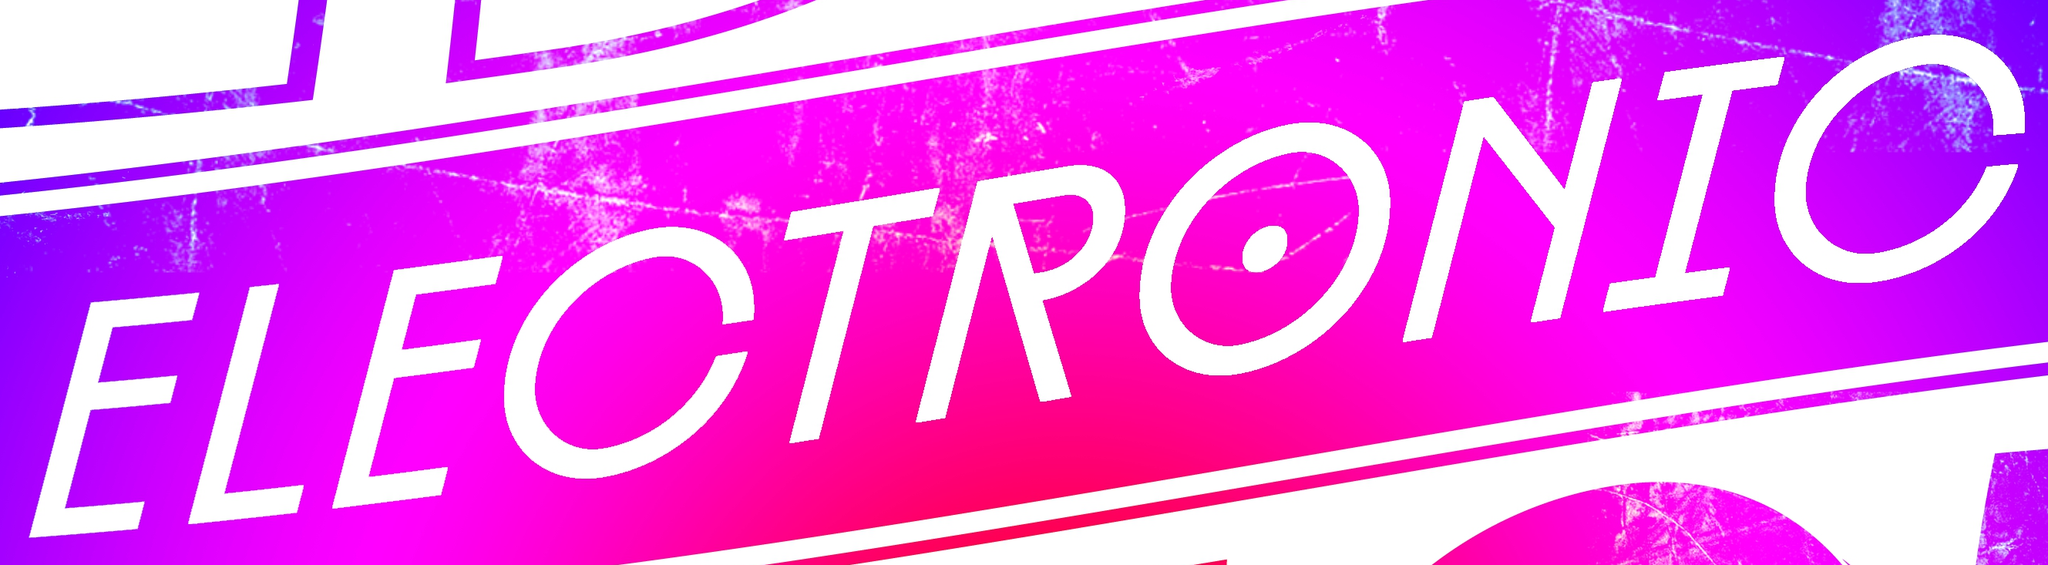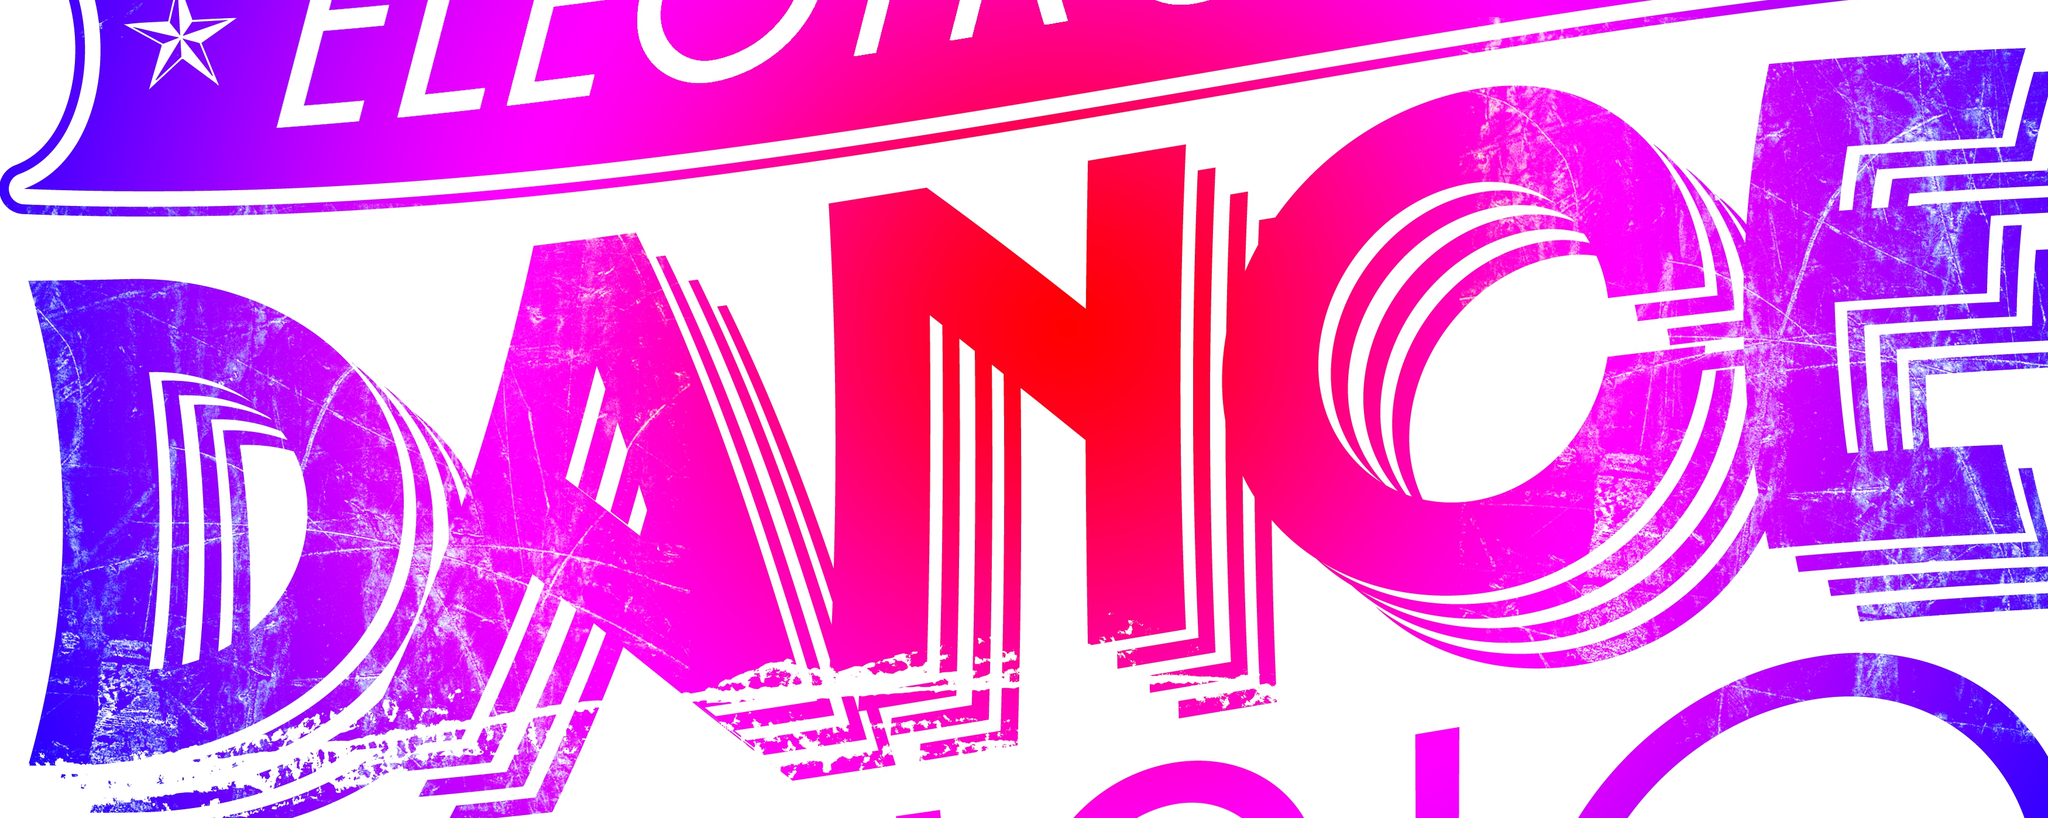What words are shown in these images in order, separated by a semicolon? ELECTRONIC; DANCE 